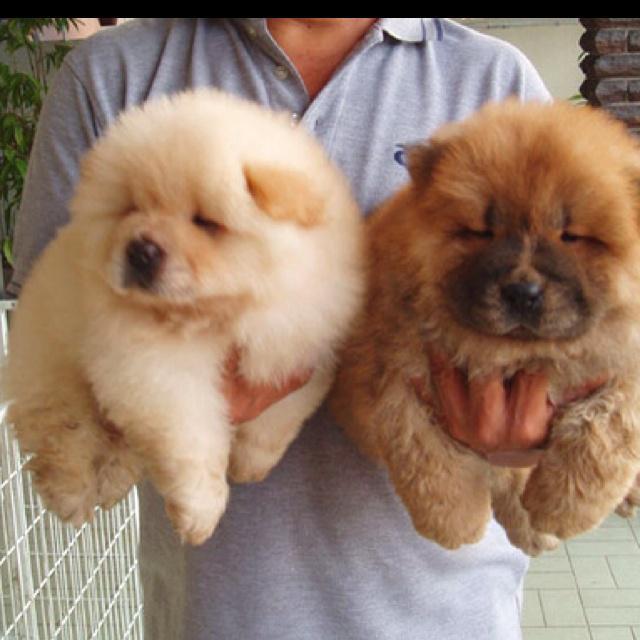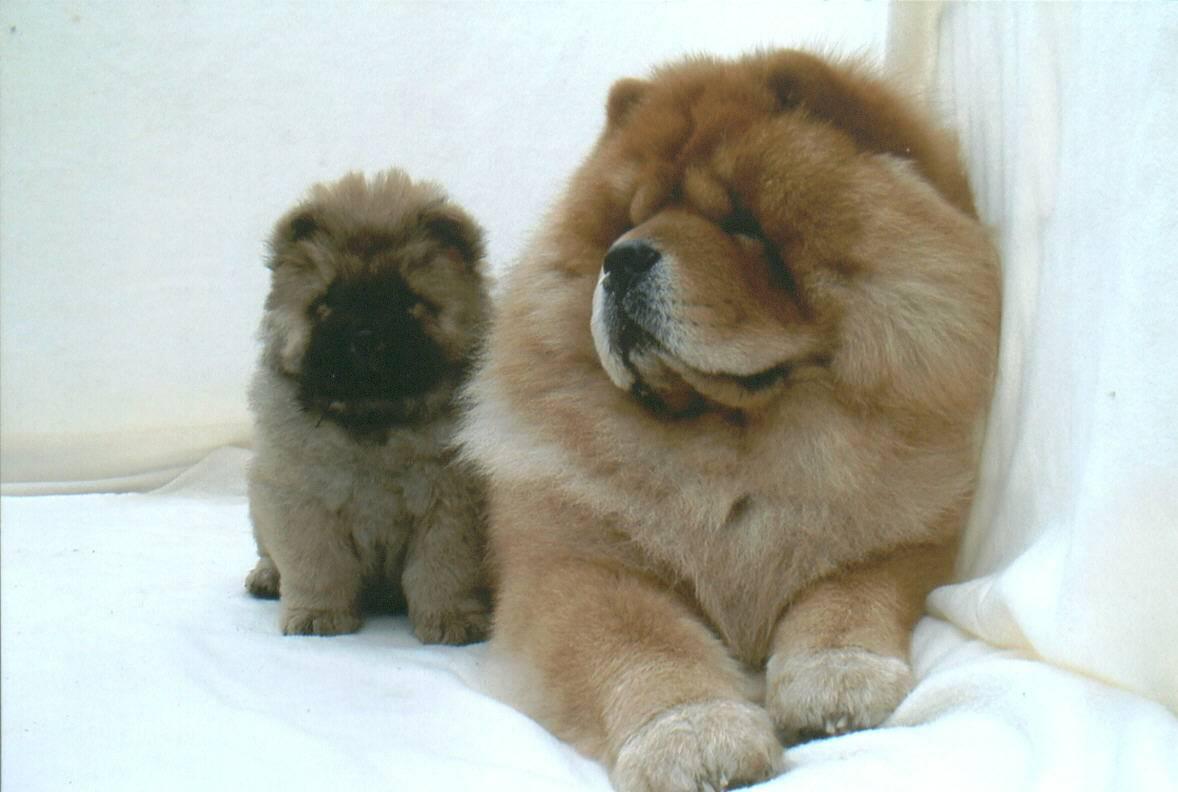The first image is the image on the left, the second image is the image on the right. For the images displayed, is the sentence "There are at most two dogs." factually correct? Answer yes or no. No. The first image is the image on the left, the second image is the image on the right. For the images displayed, is the sentence "The right image contains at least two chow dogs." factually correct? Answer yes or no. Yes. 